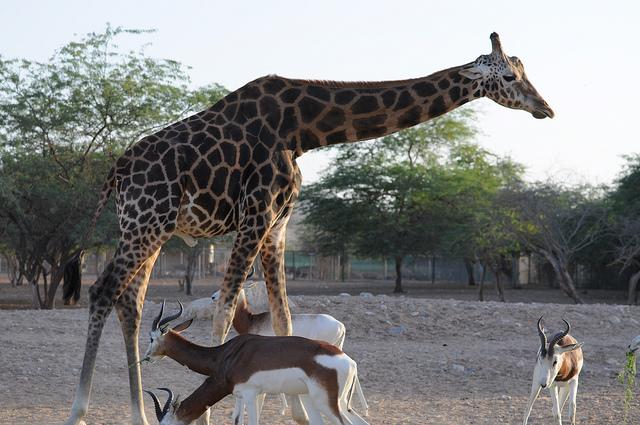How many giraffes are there?
Be succinct. 1. What are the smaller animals?
Give a very brief answer. Antelope. What is the tallest animal in the picture?
Be succinct. Giraffe. 